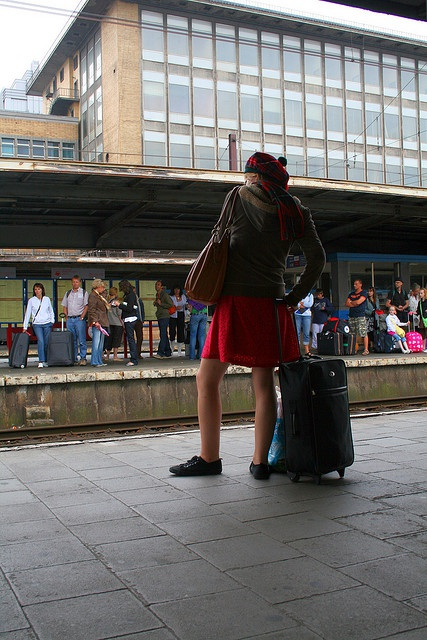Describe the objects in this image and their specific colors. I can see people in lavender, black, maroon, brown, and gray tones, suitcase in lavender, black, gray, maroon, and blue tones, people in lavender, black, gray, navy, and blue tones, handbag in lavender, black, maroon, gray, and darkgray tones, and people in lavender, darkgray, blue, black, and gray tones in this image. 